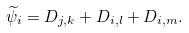<formula> <loc_0><loc_0><loc_500><loc_500>\widetilde { \psi } _ { i } = D _ { j , k } + D _ { i , l } + D _ { i , m } .</formula> 